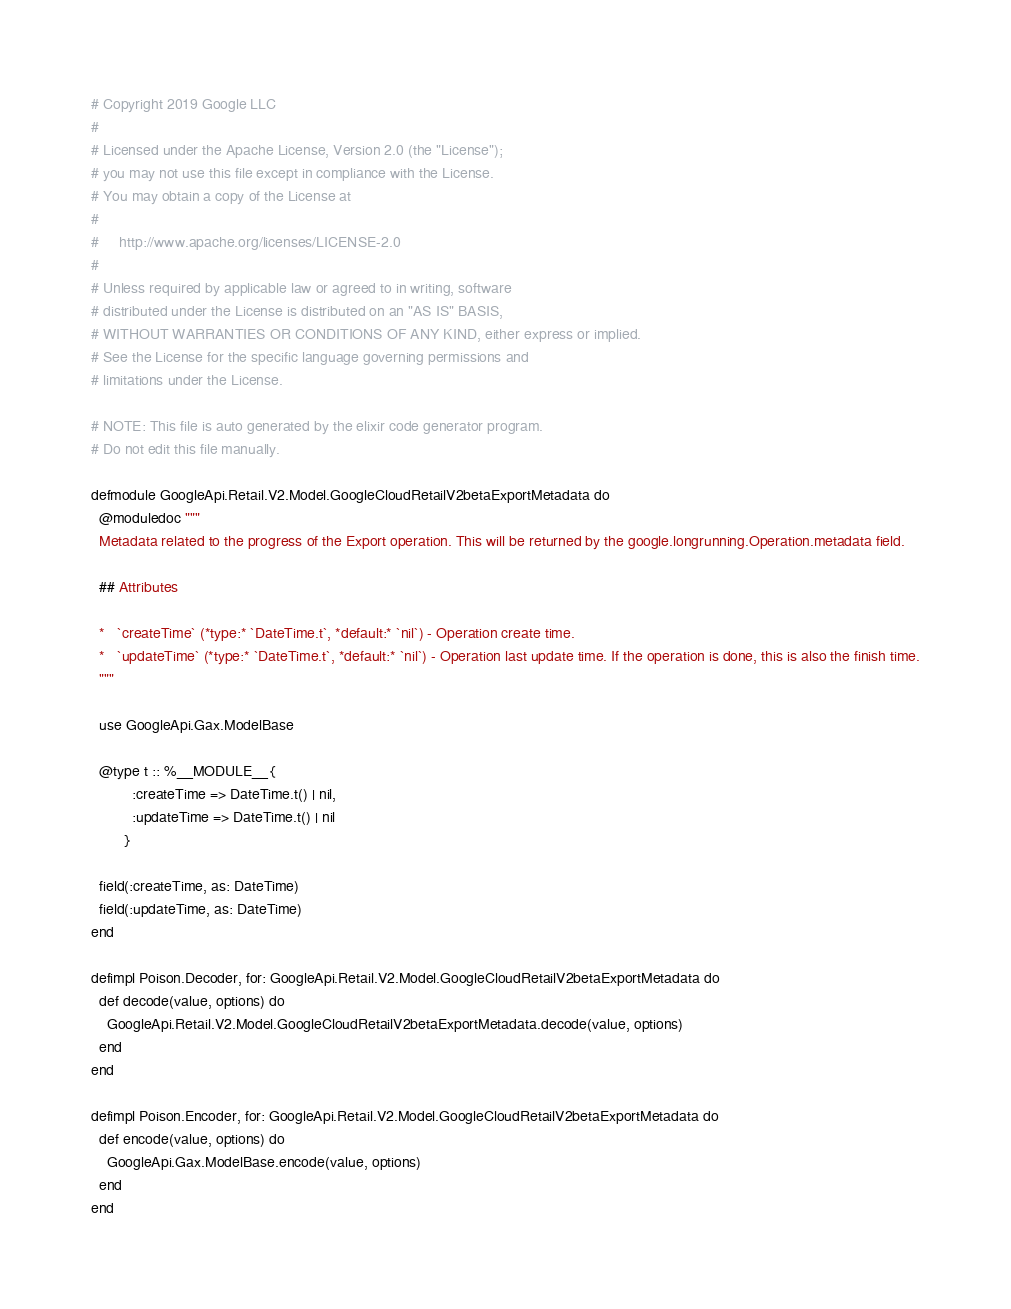Convert code to text. <code><loc_0><loc_0><loc_500><loc_500><_Elixir_># Copyright 2019 Google LLC
#
# Licensed under the Apache License, Version 2.0 (the "License");
# you may not use this file except in compliance with the License.
# You may obtain a copy of the License at
#
#     http://www.apache.org/licenses/LICENSE-2.0
#
# Unless required by applicable law or agreed to in writing, software
# distributed under the License is distributed on an "AS IS" BASIS,
# WITHOUT WARRANTIES OR CONDITIONS OF ANY KIND, either express or implied.
# See the License for the specific language governing permissions and
# limitations under the License.

# NOTE: This file is auto generated by the elixir code generator program.
# Do not edit this file manually.

defmodule GoogleApi.Retail.V2.Model.GoogleCloudRetailV2betaExportMetadata do
  @moduledoc """
  Metadata related to the progress of the Export operation. This will be returned by the google.longrunning.Operation.metadata field.

  ## Attributes

  *   `createTime` (*type:* `DateTime.t`, *default:* `nil`) - Operation create time.
  *   `updateTime` (*type:* `DateTime.t`, *default:* `nil`) - Operation last update time. If the operation is done, this is also the finish time.
  """

  use GoogleApi.Gax.ModelBase

  @type t :: %__MODULE__{
          :createTime => DateTime.t() | nil,
          :updateTime => DateTime.t() | nil
        }

  field(:createTime, as: DateTime)
  field(:updateTime, as: DateTime)
end

defimpl Poison.Decoder, for: GoogleApi.Retail.V2.Model.GoogleCloudRetailV2betaExportMetadata do
  def decode(value, options) do
    GoogleApi.Retail.V2.Model.GoogleCloudRetailV2betaExportMetadata.decode(value, options)
  end
end

defimpl Poison.Encoder, for: GoogleApi.Retail.V2.Model.GoogleCloudRetailV2betaExportMetadata do
  def encode(value, options) do
    GoogleApi.Gax.ModelBase.encode(value, options)
  end
end
</code> 